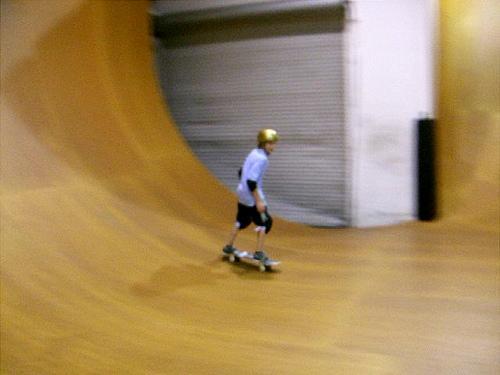Describe the complex reasoning task that could be performed with the provided image information. Analyze the boy's skateboarding skills and the safety level of his environment by taking into account his attire, the ramp's quality, and surrounding objects. Count the number of objects related to the boy's outfit and describe them. 5 objects: gold helmet, blue and black shirt, black and white shorts, black and white sneakers, and black elbow sleeves. Which object in the image is the largest? The large wooden skateboard ramp is the largest object in the image. What are some features of the environment surrounding the boy? There is a metal roll down gate, a white dirty wall, a black door, and a dark doorway near the wooden ramp. Analyze the sentiment conveyed by the image. The image conveys a positive and energetic sentiment as the boy is actively skateboarding on a ramp. How many objects are mentioned that are directly involved with the boy's skateboarding activity? 4 objects: the boy, the skateboard, the wooden ramp, and the skate board wheel. Identify the color of the boy's helmet and shirt. The boy is wearing a gold helmet and a blue and black shirt. Perform a quality assessment of the image based on the objects and details mentioned. The image is of moderate quality with various objects and details clearly mentioned, allowing for accurate object interactions and recognition. What is the main action of the boy in the image? The boy is skateboarding on a wooden ramp. Name two colors that stand out in the image, based on the objects described. Blue from the boy's shirt and gold from his helmet stand out in the image. Is the skateboarder indoors or outdoors? Indoors. Is the boy wearing a green helmet while skateboarding? In the image, the helmet is consistently described as gold, not green. Identify the color of the skateboarder's shirt and shorts. Blue and black shirt, black and white shorts. What color are the elbow sleeves on the skateboarder? Black. What mood does the image convey? Energetic and active. Match the description "boy wearing a gold helmet" to the objects in the image. X:228 Y:107 Width:52 Height:52 Describe the appearance of the wall in the image. White and dirty. What is the color of the skateboarder's shoes? Black and white. Detect any anomalies or unusual objects in the image. No significant anomalies detected. Where is the shadow of the skateboarder located in the image? X:125 Y:252 Width:81 Height:81 Can you find a red door in the background of the photo? The door in the image is described as black and grey, not red. Is the skateboarder's shirt orange and green in the picture? The skateboarder's shirt is described as blue and black, not orange and green. Does the skateboarder have a silver helmet on his head? The helmet is consistently described as gold or golden, not silver. Determine the materials of the ramp and the gate in the image. Ramp is wooden, gate is metallic. Based on the statement "a skateboard on a ramp", which object coordinates are the most relevant? X:214 Y:220 Width:89 Height:89 Identify the type of ramp in the image. Wooden ramp. What color is the door in the image? Grey. What color is the skateboard? Brown. Are there any visible texts in the image? No visible texts found. Analyze the interaction between the skateboarder and the ramp. The skateboarder is performing a trick on the wooden ramp. Can you see the skateboarder wearing orange shoes on the ramp? The skateboarder's shoes are described as black and white sneakers, not orange shoes. Which object in the image is described as "a light spot on a wooden ramp"? X:281 Y:240 Width:100 Height:100 Evaluate the quality of the image. Moderate quality with clear object details. Describe the main activity performed by the boy in the image. The boy is skateboarding. Is there any visible text on the skateboarder's clothing or skateboard? No visible text. Is there a large metal skateboard ramp in the image? The skateboard ramp is described as wooden, not metal. 